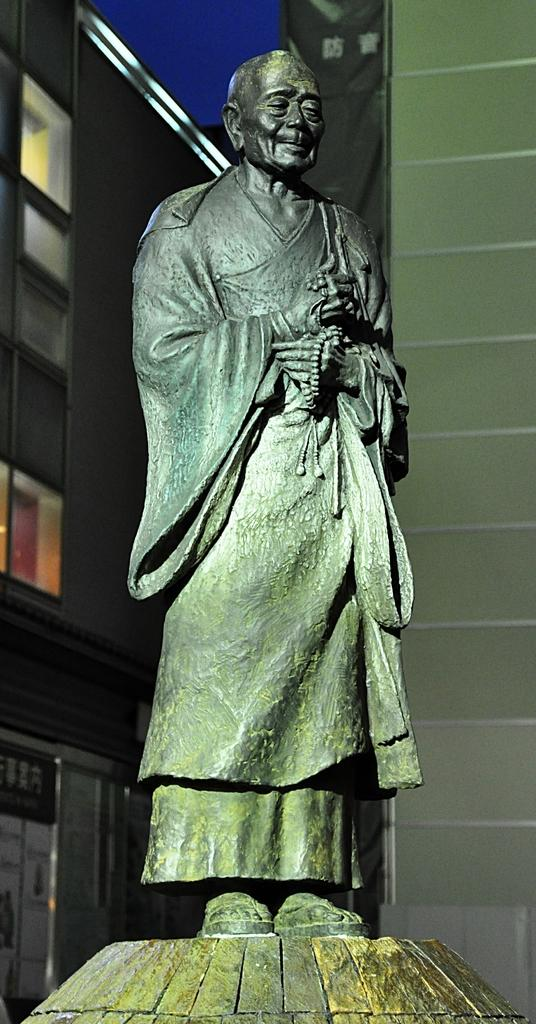What is the main subject in the middle of the image? There is a statue in the middle of the image. What can be seen in the distance behind the statue? There are buildings in the background of the image. What is visible at the top of the image? The sky is visible at the top of the image. What is on the right side of the image? There is a wall on the right side of the image. Is the pencil used to draw the statue in the image? There is no pencil present in the image, and the statue is not a drawing. Can you tell me how many people are biting the statue in the image? There are no people biting the statue in the image; it is a stationary object. 